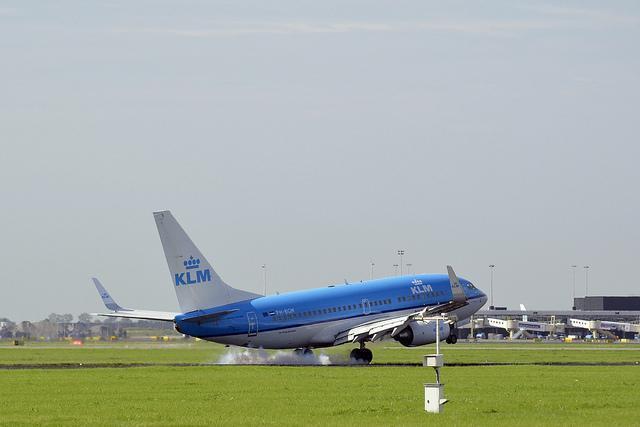How many exits are shown?
Give a very brief answer. 2. How many people are sitting down?
Give a very brief answer. 0. 